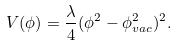Convert formula to latex. <formula><loc_0><loc_0><loc_500><loc_500>V ( \phi ) = \frac { \lambda } { 4 } ( \phi ^ { 2 } - \phi _ { v a c } ^ { 2 } ) ^ { 2 } .</formula> 